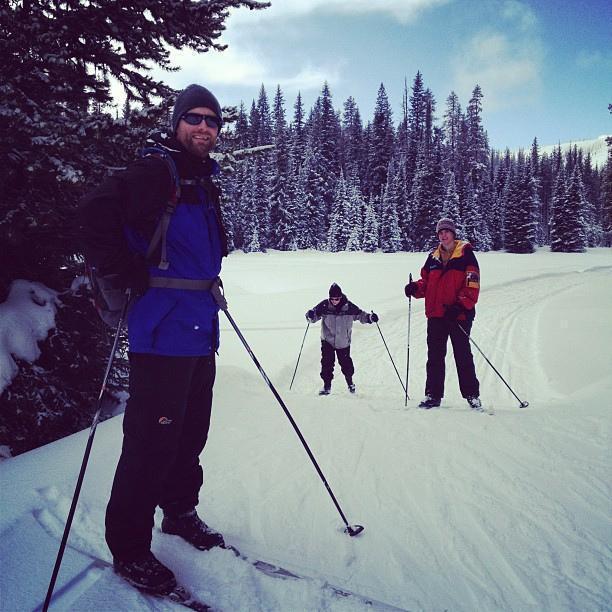Who is skiing with the man in front?
Select the accurate answer and provide explanation: 'Answer: answer
Rationale: rationale.'
Options: His grandmother, no one, someone unseen, those behind. Answer: those behind.
Rationale: The person is in front of the others. 